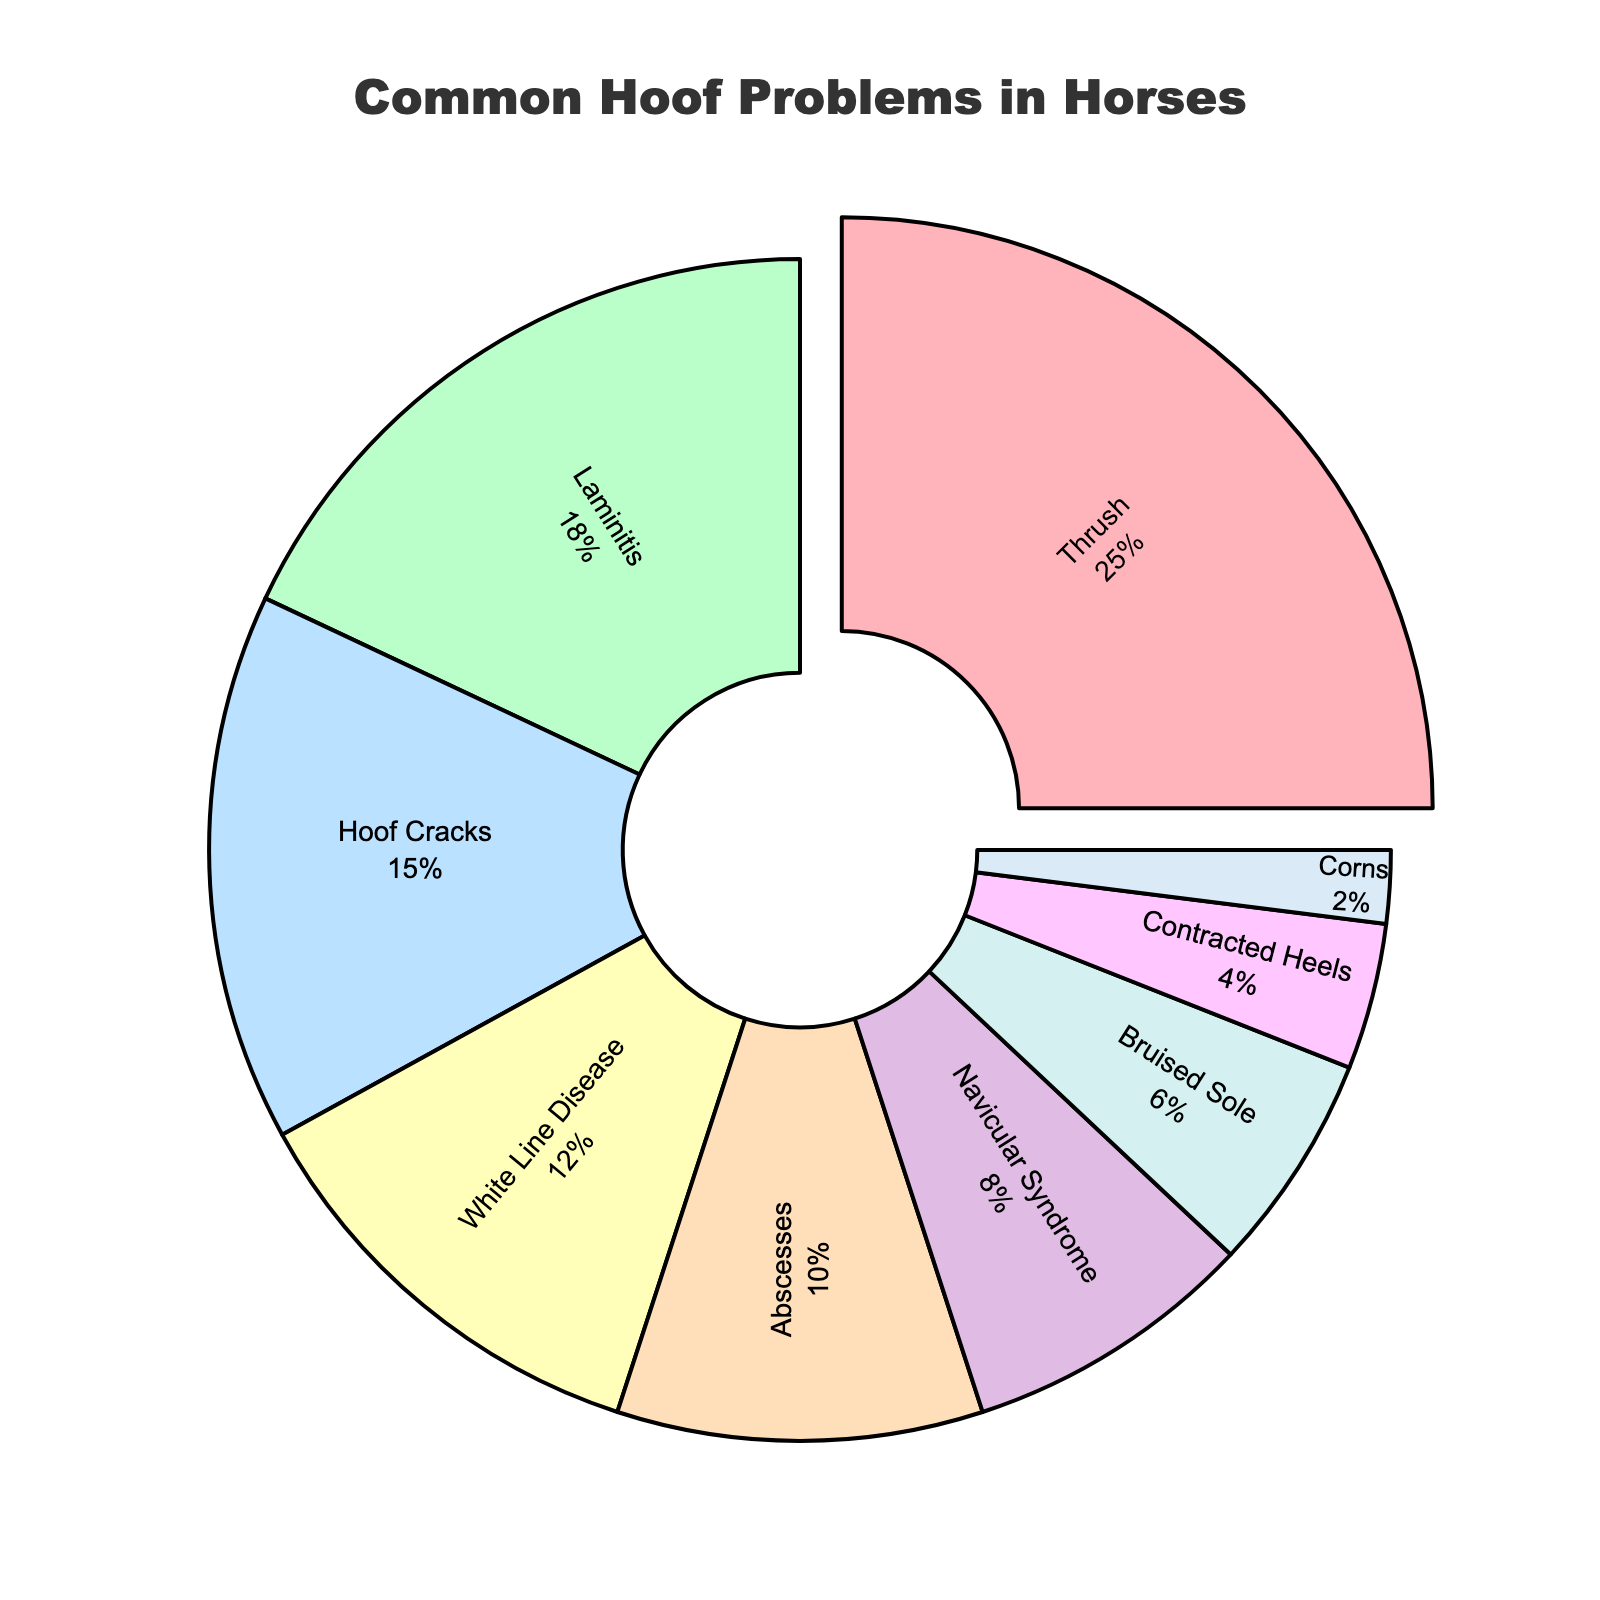What's the most common hoof problem in horses according to the data? The most common hoof problem in horses is the one with the highest percentage. In the figure, Thrush has the highest percentage at 25%.
Answer: Thrush How much more common is Thrush compared to Navicular Syndrome? Thrush has a percentage of 25%, while Navicular Syndrome has a percentage of 8%. The difference can be calculated as 25% - 8% = 17%.
Answer: 17% Which hoof problem has a higher occurrence: Hoof Cracks or White Line Disease? According to the pie chart, Hoof Cracks have a percentage of 15%, while White Line Disease has a percentage of 12%. Therefore, Hoof Cracks have a higher occurrence.
Answer: Hoof Cracks What percentage of hoof problems is attributed to Abscesses and Corns combined? The percentage for Abscesses is 10%, and for Corns is 2%. Combined, they account for 10% + 2% = 12%.
Answer: 12% Identify the hoof problem represented by the smallest slice in the pie chart. The smallest slice corresponds to the lowest percentage value. In this case, Corns represent the smallest slice with 2%.
Answer: Corns What color represents the percentage of Hoof Cracks in the pie chart? By matching the labeling to the color used in the pie chart, Hoof Cracks are represented by a specific color. According to the data provided, Hoof Cracks are associated with the color blue (#BAE1FF).
Answer: Blue How does the percentage of Laminitis compare to the combined percentage of Bruised Sole and Contracted Heels? Laminitis has a percentage of 18%. Bruised Sole has 6%, and Contracted Heels have 4%. Combined, Bruised Sole and Contracted Heels account for 6% + 4% = 10%. So, Laminitis is 18% - 10% = 8% more than the combined percentage of Bruised Sole and Contracted Heels.
Answer: 8% Which problem is more common, Abscesses or Contracted Heels? According to the pie chart, Abscesses have a percentage of 10%, while Contracted Heels have a percentage of 4%. Therefore, Abscesses are more common.
Answer: Abscesses What is the second most common hoof problem according to the figure? The second most common hoof problem would be the one with the second highest percentage. From the pie chart, after Thrush (25%), Laminitis has the next highest percentage at 18%.
Answer: Laminitis What's the total percentage of hoof problems other than Thrush? Thrush accounts for 25%. To find the total percentage of other hoof problems, subtract Thrush's percentage from 100%. Therefore, it is 100% - 25% = 75%.
Answer: 75% 